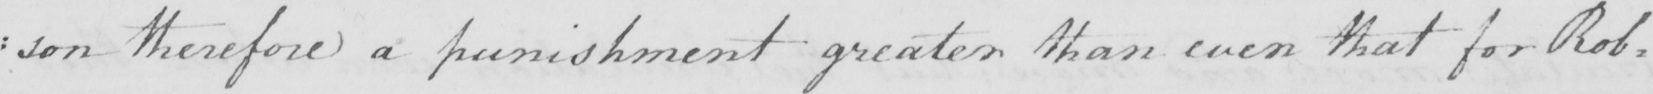What text is written in this handwritten line? : son therefore a punishment greater than even that for Rob= 